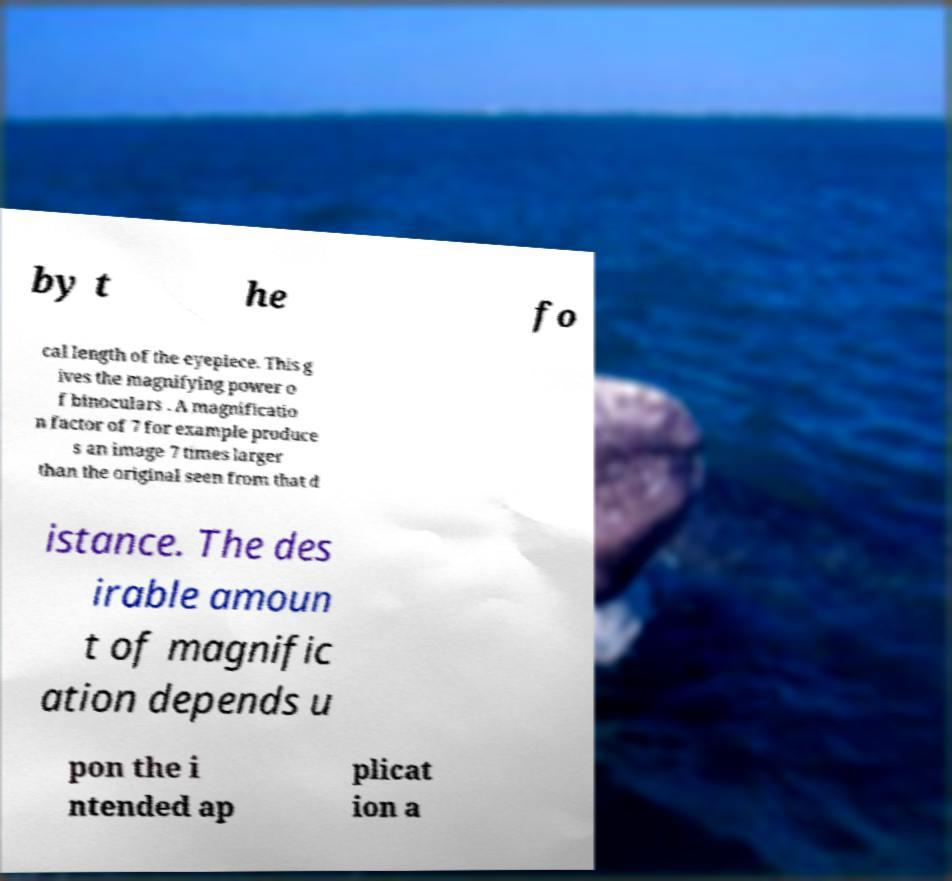I need the written content from this picture converted into text. Can you do that? by t he fo cal length of the eyepiece. This g ives the magnifying power o f binoculars . A magnificatio n factor of 7 for example produce s an image 7 times larger than the original seen from that d istance. The des irable amoun t of magnific ation depends u pon the i ntended ap plicat ion a 